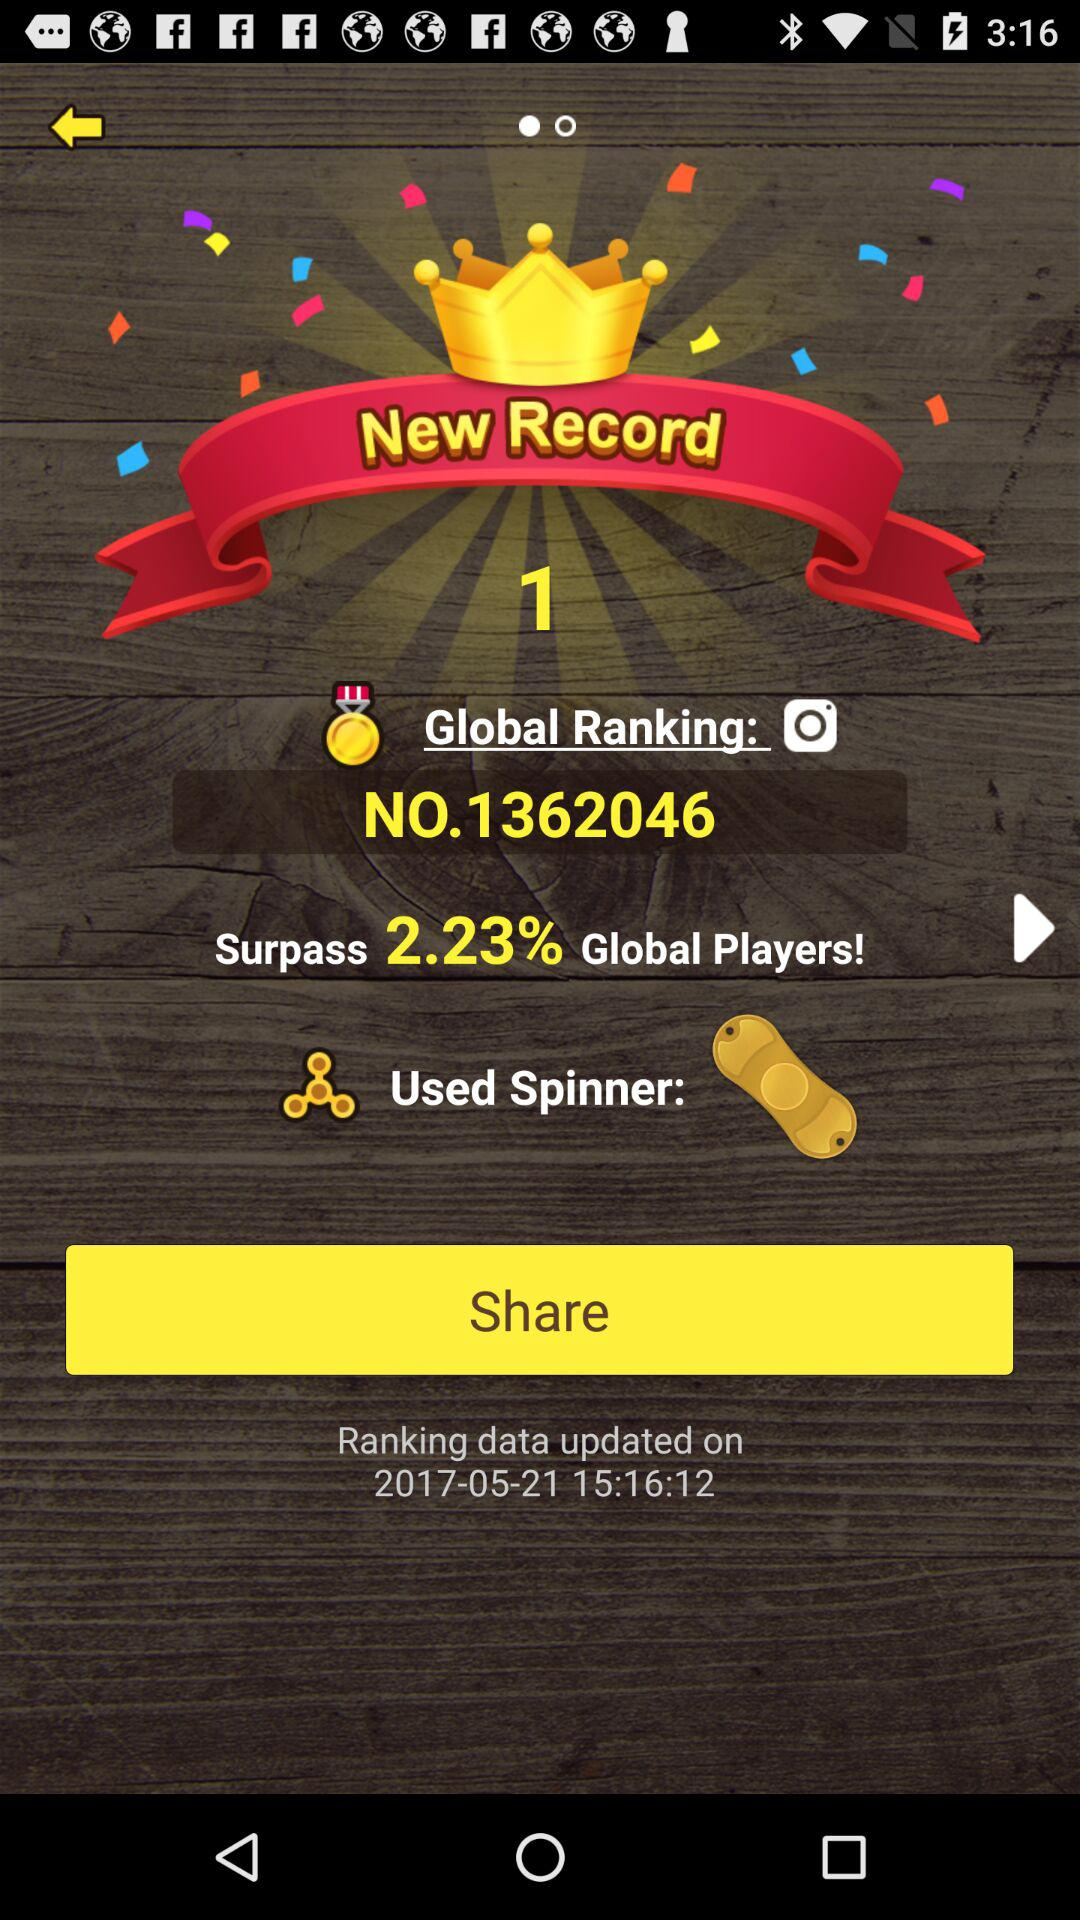What is the percentage of global players that I have surpassed?
Answer the question using a single word or phrase. 2.23% 